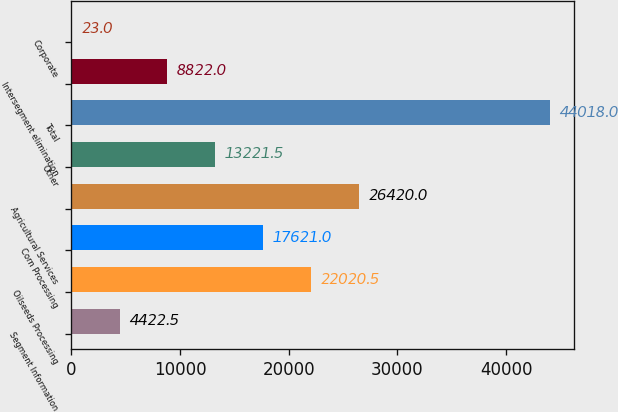Convert chart to OTSL. <chart><loc_0><loc_0><loc_500><loc_500><bar_chart><fcel>Segment Information<fcel>Oilseeds Processing<fcel>Corn Processing<fcel>Agricultural Services<fcel>Other<fcel>Total<fcel>Intersegment elimination<fcel>Corporate<nl><fcel>4422.5<fcel>22020.5<fcel>17621<fcel>26420<fcel>13221.5<fcel>44018<fcel>8822<fcel>23<nl></chart> 